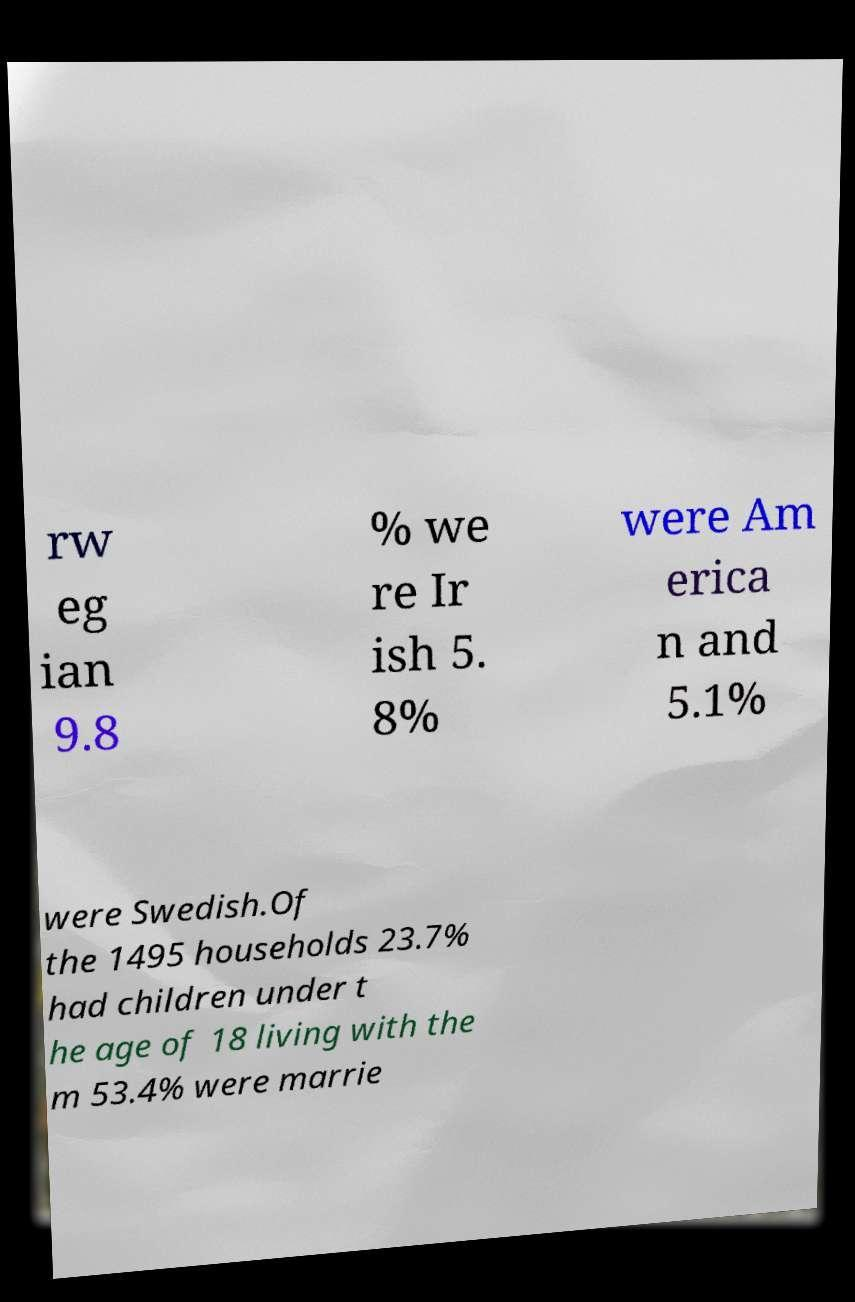For documentation purposes, I need the text within this image transcribed. Could you provide that? rw eg ian 9.8 % we re Ir ish 5. 8% were Am erica n and 5.1% were Swedish.Of the 1495 households 23.7% had children under t he age of 18 living with the m 53.4% were marrie 